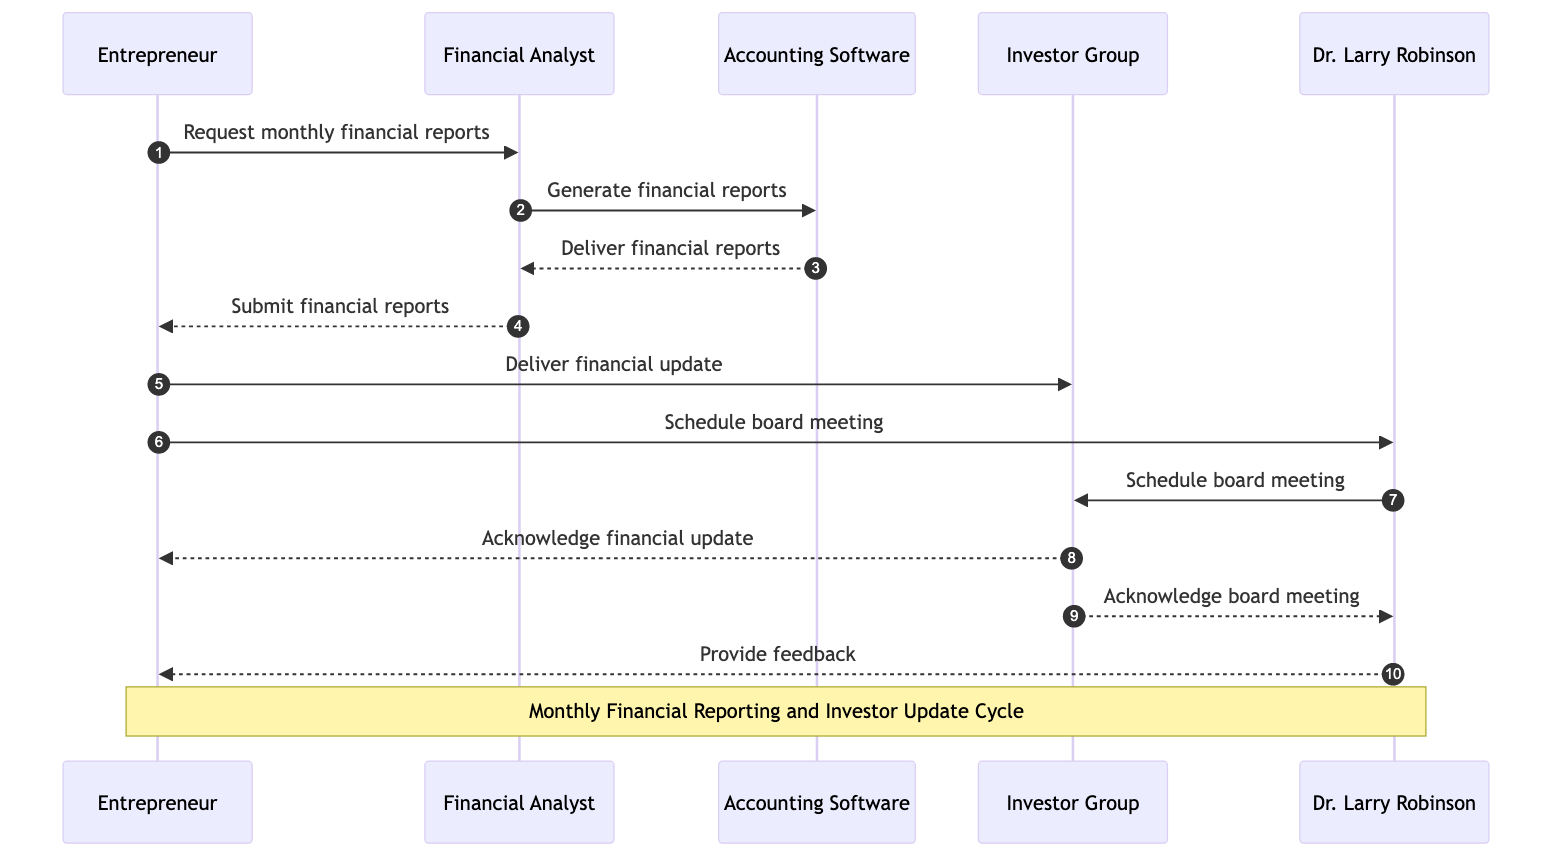What is the first action in the sequence? The first action is initiated by John, where he requests the monthly financial reports from Sarah. This is outlined as the first step in the sequence diagram.
Answer: Request monthly financial reports Who generates the financial reports? The financial reports are generated by Sarah, who is the financial analyst in the sequence diagram. This is seen in the second action where Sarah communicates with QuickBooks to generate the reports.
Answer: Sarah How many actors are present in the diagram? The diagram includes a total of five actors: John, Sarah, QuickBooks, Investor Group, and Dr. Larry Robinson. Counting them gives the number five.
Answer: Five What does John do after receiving the financial reports? After receiving the financial reports from Sarah, John delivers the financial update to the Investor Group. This is the fifth step in the sequence.
Answer: Deliver financial update What type of response does the Investor Group give after the financial update? The Investor Group acknowledges the financial update from John. This acknowledgment is outlined specifically in a message exchanged between them.
Answer: Acknowledge financial update Who provides feedback to John? Feedback is provided to John by Dr. Larry Robinson. This interaction occurs as one of the final steps in the sequence diagram where Dr. Larry Robinson communicates back to John.
Answer: Dr. Larry Robinson What is the purpose of the board meeting scheduled by John? The board meeting scheduled by John aims to discuss the financial status and updates with Dr. Larry Robinson. This is indicated by John's action to schedule the meeting after providing the financial update.
Answer: Schedule board meeting What happens to the financial reports after QuickBooks generates them? QuickBooks delivers the financial reports to Sarah after generating them, as detailed in the third step of the sequence.
Answer: Deliver financial reports How many messages are exchanged between John and the Investor Group? There are two messages exchanged between John and the Investor Group: one for the financial update and one acknowledgment from the Investor Group. This can be verified by counting the messages in the sequence.
Answer: Two 